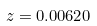Convert formula to latex. <formula><loc_0><loc_0><loc_500><loc_500>z = 0 . 0 0 6 2 0</formula> 